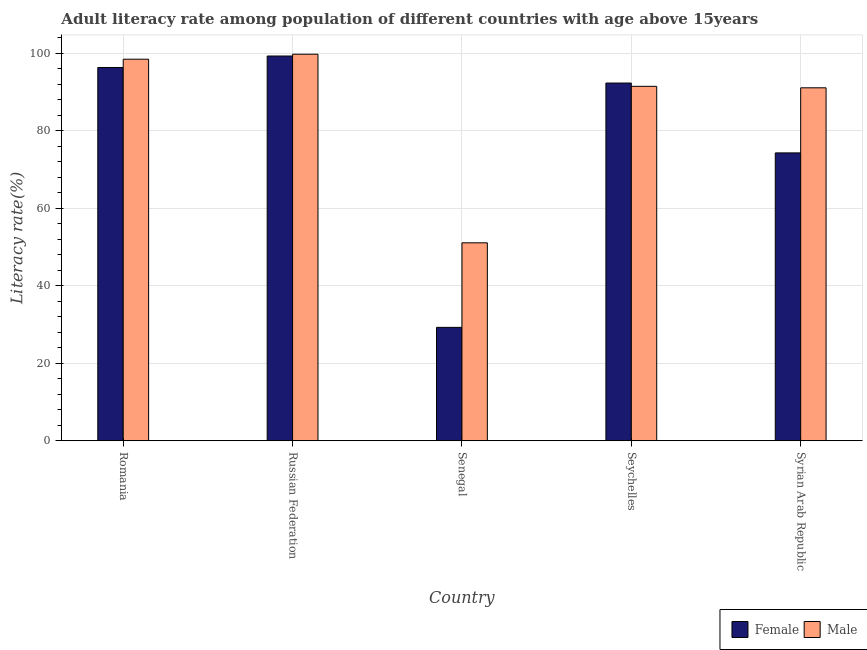How many different coloured bars are there?
Provide a short and direct response. 2. Are the number of bars on each tick of the X-axis equal?
Make the answer very short. Yes. What is the label of the 5th group of bars from the left?
Keep it short and to the point. Syrian Arab Republic. In how many cases, is the number of bars for a given country not equal to the number of legend labels?
Give a very brief answer. 0. What is the female adult literacy rate in Senegal?
Make the answer very short. 29.25. Across all countries, what is the maximum female adult literacy rate?
Your answer should be compact. 99.23. Across all countries, what is the minimum male adult literacy rate?
Ensure brevity in your answer.  51.05. In which country was the male adult literacy rate maximum?
Your response must be concise. Russian Federation. In which country was the male adult literacy rate minimum?
Your response must be concise. Senegal. What is the total female adult literacy rate in the graph?
Give a very brief answer. 391.24. What is the difference between the male adult literacy rate in Romania and that in Russian Federation?
Your response must be concise. -1.29. What is the difference between the male adult literacy rate in Senegal and the female adult literacy rate in Russian Federation?
Make the answer very short. -48.18. What is the average male adult literacy rate per country?
Provide a succinct answer. 86.32. What is the difference between the female adult literacy rate and male adult literacy rate in Russian Federation?
Provide a succinct answer. -0.47. In how many countries, is the male adult literacy rate greater than 56 %?
Offer a terse response. 4. What is the ratio of the male adult literacy rate in Russian Federation to that in Syrian Arab Republic?
Give a very brief answer. 1.1. Is the female adult literacy rate in Romania less than that in Russian Federation?
Ensure brevity in your answer.  Yes. What is the difference between the highest and the second highest female adult literacy rate?
Your response must be concise. 2.96. What is the difference between the highest and the lowest male adult literacy rate?
Your answer should be very brief. 48.64. In how many countries, is the male adult literacy rate greater than the average male adult literacy rate taken over all countries?
Your answer should be compact. 4. Is the sum of the female adult literacy rate in Senegal and Seychelles greater than the maximum male adult literacy rate across all countries?
Give a very brief answer. Yes. What does the 2nd bar from the left in Senegal represents?
Offer a very short reply. Male. Are all the bars in the graph horizontal?
Ensure brevity in your answer.  No. Are the values on the major ticks of Y-axis written in scientific E-notation?
Your answer should be compact. No. Does the graph contain any zero values?
Your answer should be compact. No. Where does the legend appear in the graph?
Provide a succinct answer. Bottom right. How many legend labels are there?
Keep it short and to the point. 2. How are the legend labels stacked?
Make the answer very short. Horizontal. What is the title of the graph?
Offer a terse response. Adult literacy rate among population of different countries with age above 15years. What is the label or title of the Y-axis?
Make the answer very short. Literacy rate(%). What is the Literacy rate(%) in Female in Romania?
Offer a terse response. 96.27. What is the Literacy rate(%) in Male in Romania?
Your answer should be compact. 98.4. What is the Literacy rate(%) in Female in Russian Federation?
Your response must be concise. 99.23. What is the Literacy rate(%) of Male in Russian Federation?
Your response must be concise. 99.69. What is the Literacy rate(%) in Female in Senegal?
Make the answer very short. 29.25. What is the Literacy rate(%) of Male in Senegal?
Keep it short and to the point. 51.05. What is the Literacy rate(%) in Female in Seychelles?
Ensure brevity in your answer.  92.26. What is the Literacy rate(%) in Male in Seychelles?
Give a very brief answer. 91.41. What is the Literacy rate(%) in Female in Syrian Arab Republic?
Give a very brief answer. 74.24. What is the Literacy rate(%) in Male in Syrian Arab Republic?
Your response must be concise. 91.03. Across all countries, what is the maximum Literacy rate(%) in Female?
Provide a succinct answer. 99.23. Across all countries, what is the maximum Literacy rate(%) of Male?
Offer a very short reply. 99.69. Across all countries, what is the minimum Literacy rate(%) in Female?
Keep it short and to the point. 29.25. Across all countries, what is the minimum Literacy rate(%) in Male?
Your answer should be compact. 51.05. What is the total Literacy rate(%) in Female in the graph?
Ensure brevity in your answer.  391.24. What is the total Literacy rate(%) of Male in the graph?
Offer a very short reply. 431.59. What is the difference between the Literacy rate(%) in Female in Romania and that in Russian Federation?
Make the answer very short. -2.96. What is the difference between the Literacy rate(%) of Male in Romania and that in Russian Federation?
Your answer should be compact. -1.29. What is the difference between the Literacy rate(%) in Female in Romania and that in Senegal?
Keep it short and to the point. 67.02. What is the difference between the Literacy rate(%) in Male in Romania and that in Senegal?
Your response must be concise. 47.35. What is the difference between the Literacy rate(%) of Female in Romania and that in Seychelles?
Your response must be concise. 4.01. What is the difference between the Literacy rate(%) of Male in Romania and that in Seychelles?
Offer a terse response. 7. What is the difference between the Literacy rate(%) of Female in Romania and that in Syrian Arab Republic?
Your response must be concise. 22.03. What is the difference between the Literacy rate(%) of Male in Romania and that in Syrian Arab Republic?
Provide a short and direct response. 7.38. What is the difference between the Literacy rate(%) of Female in Russian Federation and that in Senegal?
Keep it short and to the point. 69.98. What is the difference between the Literacy rate(%) of Male in Russian Federation and that in Senegal?
Make the answer very short. 48.64. What is the difference between the Literacy rate(%) in Female in Russian Federation and that in Seychelles?
Make the answer very short. 6.97. What is the difference between the Literacy rate(%) of Male in Russian Federation and that in Seychelles?
Your answer should be very brief. 8.29. What is the difference between the Literacy rate(%) of Female in Russian Federation and that in Syrian Arab Republic?
Provide a short and direct response. 24.99. What is the difference between the Literacy rate(%) in Male in Russian Federation and that in Syrian Arab Republic?
Make the answer very short. 8.67. What is the difference between the Literacy rate(%) in Female in Senegal and that in Seychelles?
Ensure brevity in your answer.  -63.01. What is the difference between the Literacy rate(%) of Male in Senegal and that in Seychelles?
Your answer should be compact. -40.36. What is the difference between the Literacy rate(%) in Female in Senegal and that in Syrian Arab Republic?
Give a very brief answer. -44.99. What is the difference between the Literacy rate(%) in Male in Senegal and that in Syrian Arab Republic?
Make the answer very short. -39.98. What is the difference between the Literacy rate(%) in Female in Seychelles and that in Syrian Arab Republic?
Offer a terse response. 18.02. What is the difference between the Literacy rate(%) of Male in Seychelles and that in Syrian Arab Republic?
Your answer should be very brief. 0.38. What is the difference between the Literacy rate(%) in Female in Romania and the Literacy rate(%) in Male in Russian Federation?
Your answer should be very brief. -3.43. What is the difference between the Literacy rate(%) in Female in Romania and the Literacy rate(%) in Male in Senegal?
Offer a very short reply. 45.21. What is the difference between the Literacy rate(%) of Female in Romania and the Literacy rate(%) of Male in Seychelles?
Ensure brevity in your answer.  4.86. What is the difference between the Literacy rate(%) in Female in Romania and the Literacy rate(%) in Male in Syrian Arab Republic?
Offer a very short reply. 5.24. What is the difference between the Literacy rate(%) in Female in Russian Federation and the Literacy rate(%) in Male in Senegal?
Your response must be concise. 48.18. What is the difference between the Literacy rate(%) in Female in Russian Federation and the Literacy rate(%) in Male in Seychelles?
Provide a short and direct response. 7.82. What is the difference between the Literacy rate(%) in Female in Russian Federation and the Literacy rate(%) in Male in Syrian Arab Republic?
Make the answer very short. 8.2. What is the difference between the Literacy rate(%) in Female in Senegal and the Literacy rate(%) in Male in Seychelles?
Make the answer very short. -62.16. What is the difference between the Literacy rate(%) of Female in Senegal and the Literacy rate(%) of Male in Syrian Arab Republic?
Keep it short and to the point. -61.78. What is the difference between the Literacy rate(%) of Female in Seychelles and the Literacy rate(%) of Male in Syrian Arab Republic?
Keep it short and to the point. 1.23. What is the average Literacy rate(%) of Female per country?
Your answer should be very brief. 78.25. What is the average Literacy rate(%) in Male per country?
Your response must be concise. 86.32. What is the difference between the Literacy rate(%) of Female and Literacy rate(%) of Male in Romania?
Give a very brief answer. -2.14. What is the difference between the Literacy rate(%) of Female and Literacy rate(%) of Male in Russian Federation?
Make the answer very short. -0.47. What is the difference between the Literacy rate(%) of Female and Literacy rate(%) of Male in Senegal?
Offer a very short reply. -21.8. What is the difference between the Literacy rate(%) in Female and Literacy rate(%) in Male in Seychelles?
Your answer should be very brief. 0.85. What is the difference between the Literacy rate(%) of Female and Literacy rate(%) of Male in Syrian Arab Republic?
Offer a very short reply. -16.79. What is the ratio of the Literacy rate(%) of Female in Romania to that in Russian Federation?
Ensure brevity in your answer.  0.97. What is the ratio of the Literacy rate(%) in Male in Romania to that in Russian Federation?
Offer a very short reply. 0.99. What is the ratio of the Literacy rate(%) in Female in Romania to that in Senegal?
Your response must be concise. 3.29. What is the ratio of the Literacy rate(%) of Male in Romania to that in Senegal?
Provide a short and direct response. 1.93. What is the ratio of the Literacy rate(%) of Female in Romania to that in Seychelles?
Make the answer very short. 1.04. What is the ratio of the Literacy rate(%) in Male in Romania to that in Seychelles?
Give a very brief answer. 1.08. What is the ratio of the Literacy rate(%) of Female in Romania to that in Syrian Arab Republic?
Provide a short and direct response. 1.3. What is the ratio of the Literacy rate(%) of Male in Romania to that in Syrian Arab Republic?
Your response must be concise. 1.08. What is the ratio of the Literacy rate(%) of Female in Russian Federation to that in Senegal?
Provide a succinct answer. 3.39. What is the ratio of the Literacy rate(%) in Male in Russian Federation to that in Senegal?
Your answer should be very brief. 1.95. What is the ratio of the Literacy rate(%) in Female in Russian Federation to that in Seychelles?
Keep it short and to the point. 1.08. What is the ratio of the Literacy rate(%) of Male in Russian Federation to that in Seychelles?
Your response must be concise. 1.09. What is the ratio of the Literacy rate(%) of Female in Russian Federation to that in Syrian Arab Republic?
Offer a very short reply. 1.34. What is the ratio of the Literacy rate(%) in Male in Russian Federation to that in Syrian Arab Republic?
Provide a succinct answer. 1.1. What is the ratio of the Literacy rate(%) in Female in Senegal to that in Seychelles?
Give a very brief answer. 0.32. What is the ratio of the Literacy rate(%) of Male in Senegal to that in Seychelles?
Ensure brevity in your answer.  0.56. What is the ratio of the Literacy rate(%) of Female in Senegal to that in Syrian Arab Republic?
Keep it short and to the point. 0.39. What is the ratio of the Literacy rate(%) of Male in Senegal to that in Syrian Arab Republic?
Make the answer very short. 0.56. What is the ratio of the Literacy rate(%) in Female in Seychelles to that in Syrian Arab Republic?
Make the answer very short. 1.24. What is the difference between the highest and the second highest Literacy rate(%) in Female?
Provide a succinct answer. 2.96. What is the difference between the highest and the second highest Literacy rate(%) of Male?
Give a very brief answer. 1.29. What is the difference between the highest and the lowest Literacy rate(%) of Female?
Your answer should be very brief. 69.98. What is the difference between the highest and the lowest Literacy rate(%) of Male?
Keep it short and to the point. 48.64. 